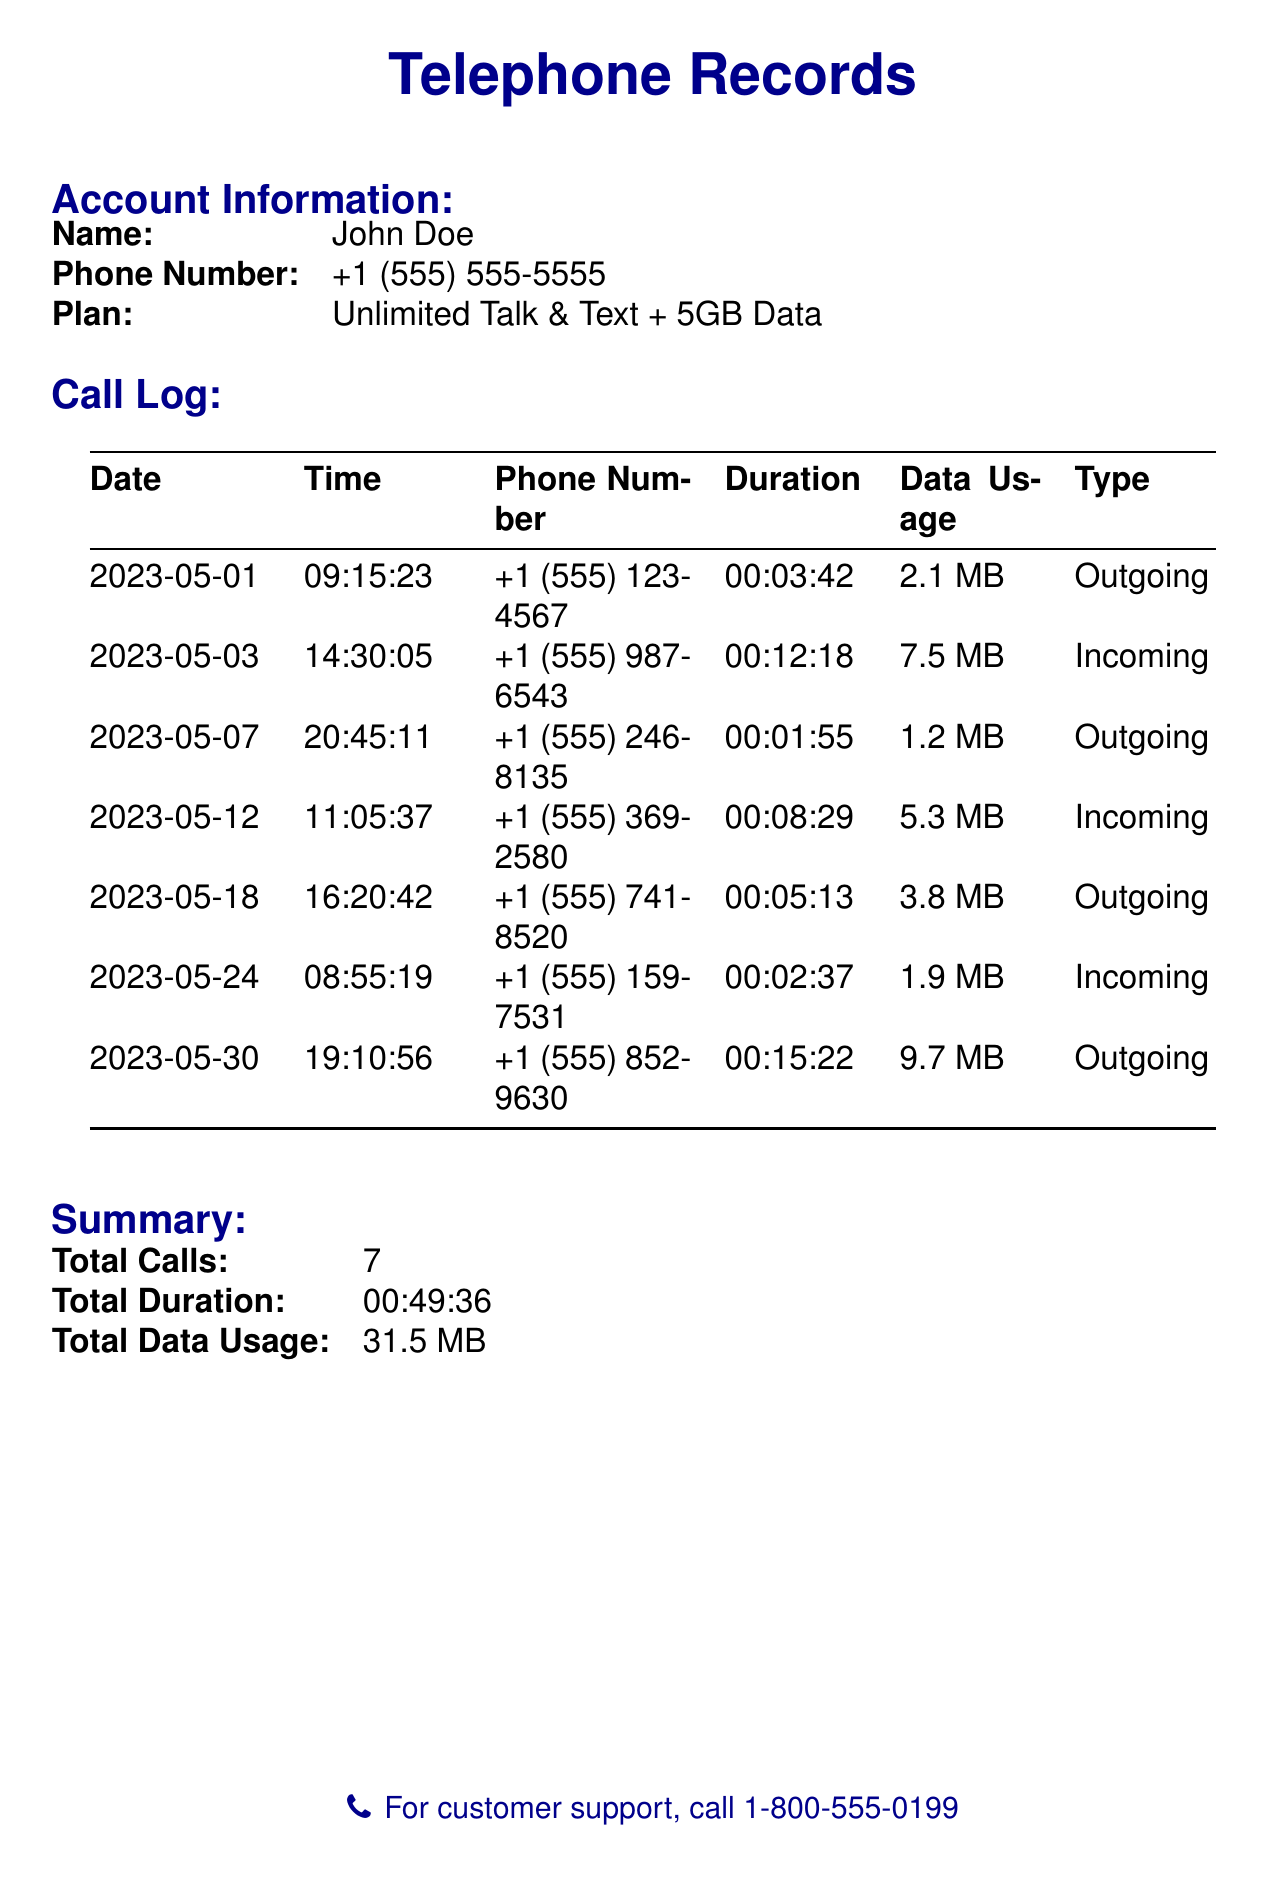What is the name of the account holder? The account holder's name is stated in the account information section of the document.
Answer: John Doe How many outgoing calls were made in May? The total number of outgoing calls can be counted from the call log, which lists each call and its type.
Answer: 4 What is the duration of the longest call? The duration of each call is listed, and the longest can be identified by comparing these durations.
Answer: 00:15:22 What was the total data usage for the month? The summary section provides a total for all data used during the month.
Answer: 31.5 MB What time was the first call made? The first call's time is noted in the call log under the date of May 1.
Answer: 09:15:23 Which phone number received an incoming call on May 12? The phone number of the incoming call made on May 12 is noted in the call log.
Answer: +1 (555) 369-2580 How many total calls were received? The total number of incoming calls can be counted from the call log, which specifies each type of call.
Answer: 3 What is the type of the call logged on May 30? The call type is specified next to each call in the call log, indicating whether the call was incoming or outgoing.
Answer: Outgoing 